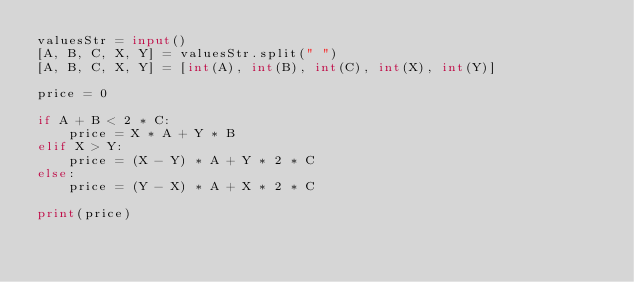Convert code to text. <code><loc_0><loc_0><loc_500><loc_500><_Python_>valuesStr = input()
[A, B, C, X, Y] = valuesStr.split(" ")
[A, B, C, X, Y] = [int(A), int(B), int(C), int(X), int(Y)]

price = 0

if A + B < 2 * C:
    price = X * A + Y * B
elif X > Y:
    price = (X - Y) * A + Y * 2 * C
else:
    price = (Y - X) * A + X * 2 * C

print(price)</code> 